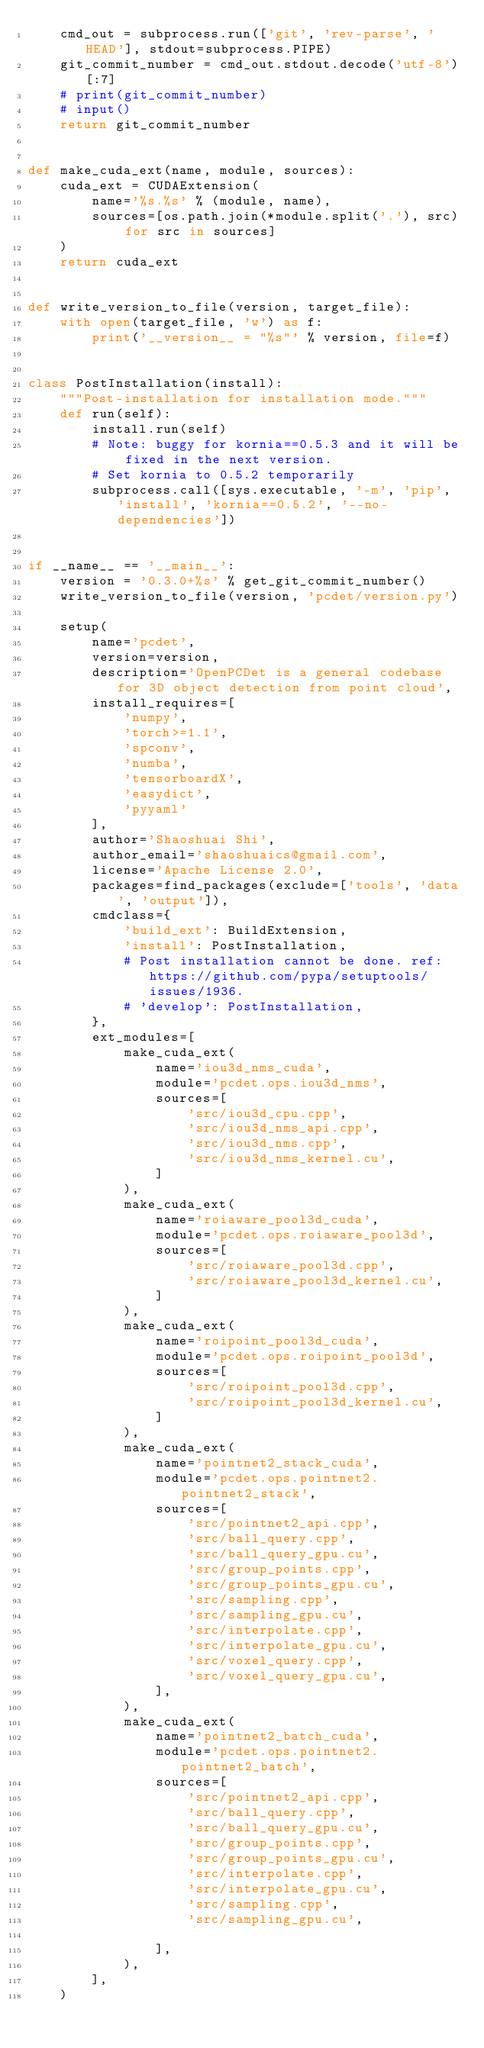Convert code to text. <code><loc_0><loc_0><loc_500><loc_500><_Python_>    cmd_out = subprocess.run(['git', 'rev-parse', 'HEAD'], stdout=subprocess.PIPE)
    git_commit_number = cmd_out.stdout.decode('utf-8')[:7]
    # print(git_commit_number)
    # input()
    return git_commit_number


def make_cuda_ext(name, module, sources):
    cuda_ext = CUDAExtension(
        name='%s.%s' % (module, name),
        sources=[os.path.join(*module.split('.'), src) for src in sources]
    )
    return cuda_ext


def write_version_to_file(version, target_file):
    with open(target_file, 'w') as f:
        print('__version__ = "%s"' % version, file=f)


class PostInstallation(install):
    """Post-installation for installation mode."""
    def run(self):
        install.run(self)
        # Note: buggy for kornia==0.5.3 and it will be fixed in the next version.
        # Set kornia to 0.5.2 temporarily
        subprocess.call([sys.executable, '-m', 'pip', 'install', 'kornia==0.5.2', '--no-dependencies'])


if __name__ == '__main__':
    version = '0.3.0+%s' % get_git_commit_number()
    write_version_to_file(version, 'pcdet/version.py')

    setup(
        name='pcdet',
        version=version,
        description='OpenPCDet is a general codebase for 3D object detection from point cloud',
        install_requires=[
            'numpy',
            'torch>=1.1',
            'spconv',
            'numba',
            'tensorboardX',
            'easydict',
            'pyyaml'
        ],
        author='Shaoshuai Shi',
        author_email='shaoshuaics@gmail.com',
        license='Apache License 2.0',
        packages=find_packages(exclude=['tools', 'data', 'output']),
        cmdclass={
            'build_ext': BuildExtension,
            'install': PostInstallation,
            # Post installation cannot be done. ref: https://github.com/pypa/setuptools/issues/1936.
            # 'develop': PostInstallation,
        },
        ext_modules=[
            make_cuda_ext(
                name='iou3d_nms_cuda',
                module='pcdet.ops.iou3d_nms',
                sources=[
                    'src/iou3d_cpu.cpp',
                    'src/iou3d_nms_api.cpp',
                    'src/iou3d_nms.cpp',
                    'src/iou3d_nms_kernel.cu',
                ]
            ),
            make_cuda_ext(
                name='roiaware_pool3d_cuda',
                module='pcdet.ops.roiaware_pool3d',
                sources=[
                    'src/roiaware_pool3d.cpp',
                    'src/roiaware_pool3d_kernel.cu',
                ]
            ),
            make_cuda_ext(
                name='roipoint_pool3d_cuda',
                module='pcdet.ops.roipoint_pool3d',
                sources=[
                    'src/roipoint_pool3d.cpp',
                    'src/roipoint_pool3d_kernel.cu',
                ]
            ),
            make_cuda_ext(
                name='pointnet2_stack_cuda',
                module='pcdet.ops.pointnet2.pointnet2_stack',
                sources=[
                    'src/pointnet2_api.cpp',
                    'src/ball_query.cpp',
                    'src/ball_query_gpu.cu',
                    'src/group_points.cpp',
                    'src/group_points_gpu.cu',
                    'src/sampling.cpp',
                    'src/sampling_gpu.cu', 
                    'src/interpolate.cpp', 
                    'src/interpolate_gpu.cu',
                    'src/voxel_query.cpp', 
                    'src/voxel_query_gpu.cu',
                ],
            ),
            make_cuda_ext(
                name='pointnet2_batch_cuda',
                module='pcdet.ops.pointnet2.pointnet2_batch',
                sources=[
                    'src/pointnet2_api.cpp',
                    'src/ball_query.cpp',
                    'src/ball_query_gpu.cu',
                    'src/group_points.cpp',
                    'src/group_points_gpu.cu',
                    'src/interpolate.cpp',
                    'src/interpolate_gpu.cu',
                    'src/sampling.cpp',
                    'src/sampling_gpu.cu',

                ],
            ),
        ],
    )
</code> 